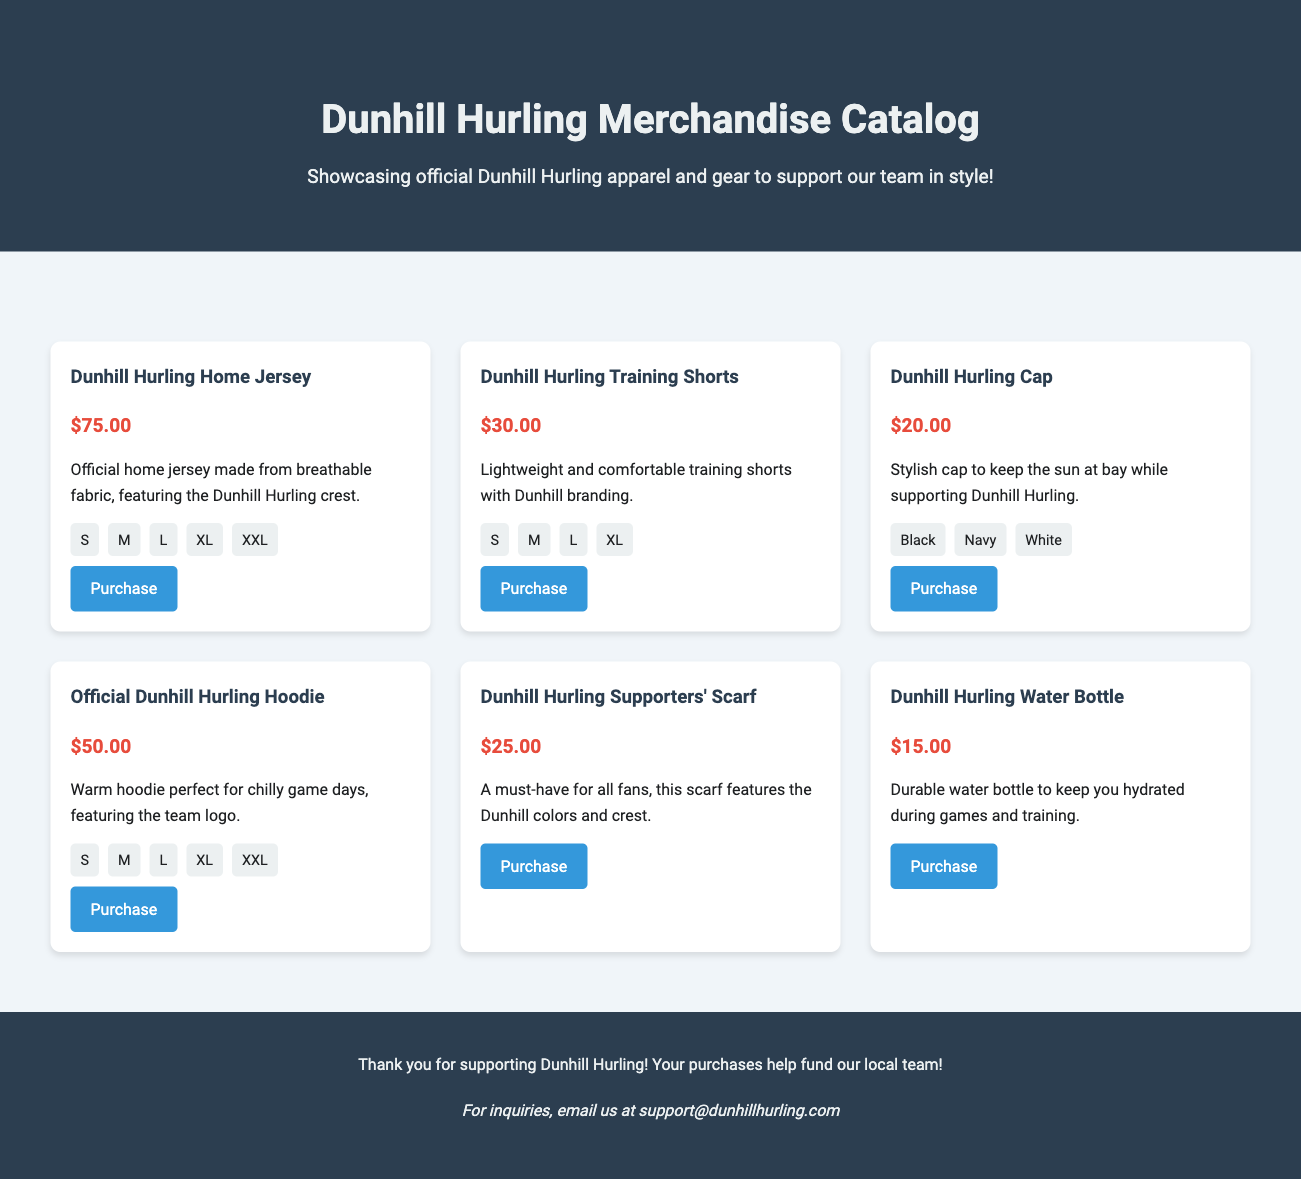What is the price of the Dunhill Hurling Home Jersey? The price of the Dunhill Hurling Home Jersey is specified directly in the document.
Answer: $75.00 How many sizes are available for the Official Dunhill Hurling Hoodie? The document lists the available sizes for the hoodie.
Answer: 5 What colors are available for the Dunhill Hurling Cap? The document provides the available colors for the cap.
Answer: Black, Navy, White What is the primary purpose of the Dunhill Hurling Supporters' Scarf? The document describes the purpose or intended use of the supporters' scarf.
Answer: A must-have for all fans What is the total number of items listed in the catalog? The total number of merchandise items is counted based on the individual item sections in the document.
Answer: 6 What does the purchase link for the Dunhill Hurling Training Shorts direct you to? The purchase link provided in the document is specific to a product, indicating where to buy it.
Answer: https://dunhillhurling.com/shop/training-shorts For which occasion is the Official Dunhill Hurling Hoodie particularly suitable? The document explicitly mentions the conditions under which the hoodie is ideal.
Answer: Chilly game days What is the item description of the Dunhill Hurling Water Bottle? The description of the water bottle is clearly stated in the document.
Answer: Durable water bottle to keep you hydrated during games and training 